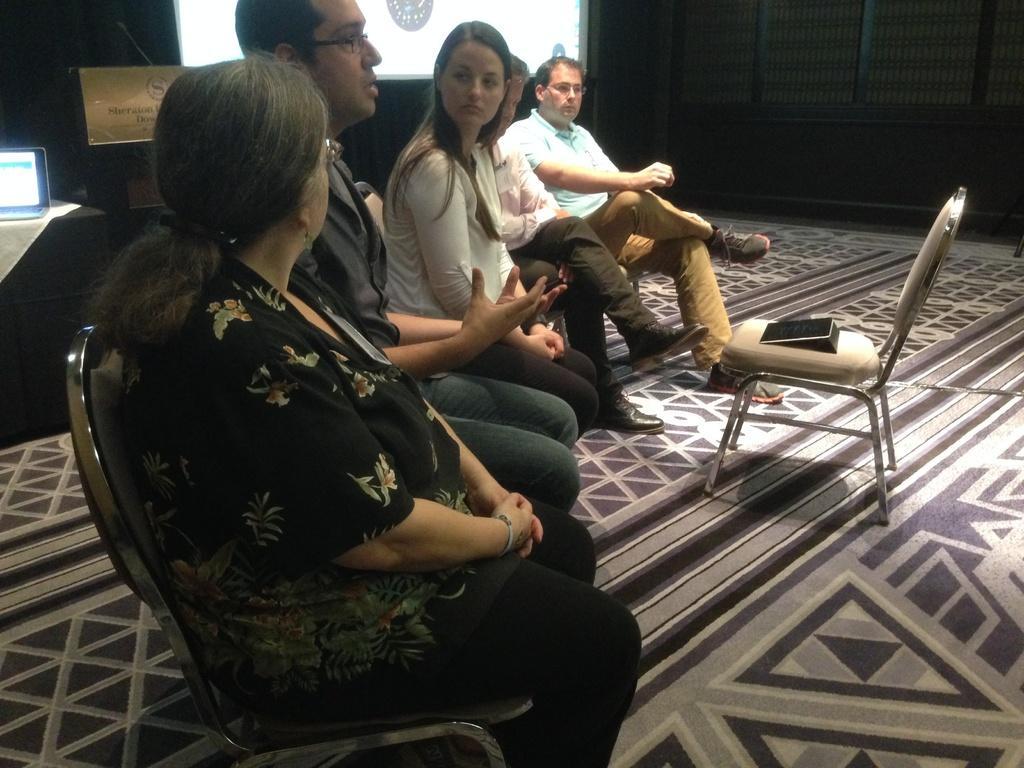Can you describe this image briefly? In this picture we can see a group of people sitting on chairs,in front of them we can see a chair and in the background we can see a laptop,screen. 